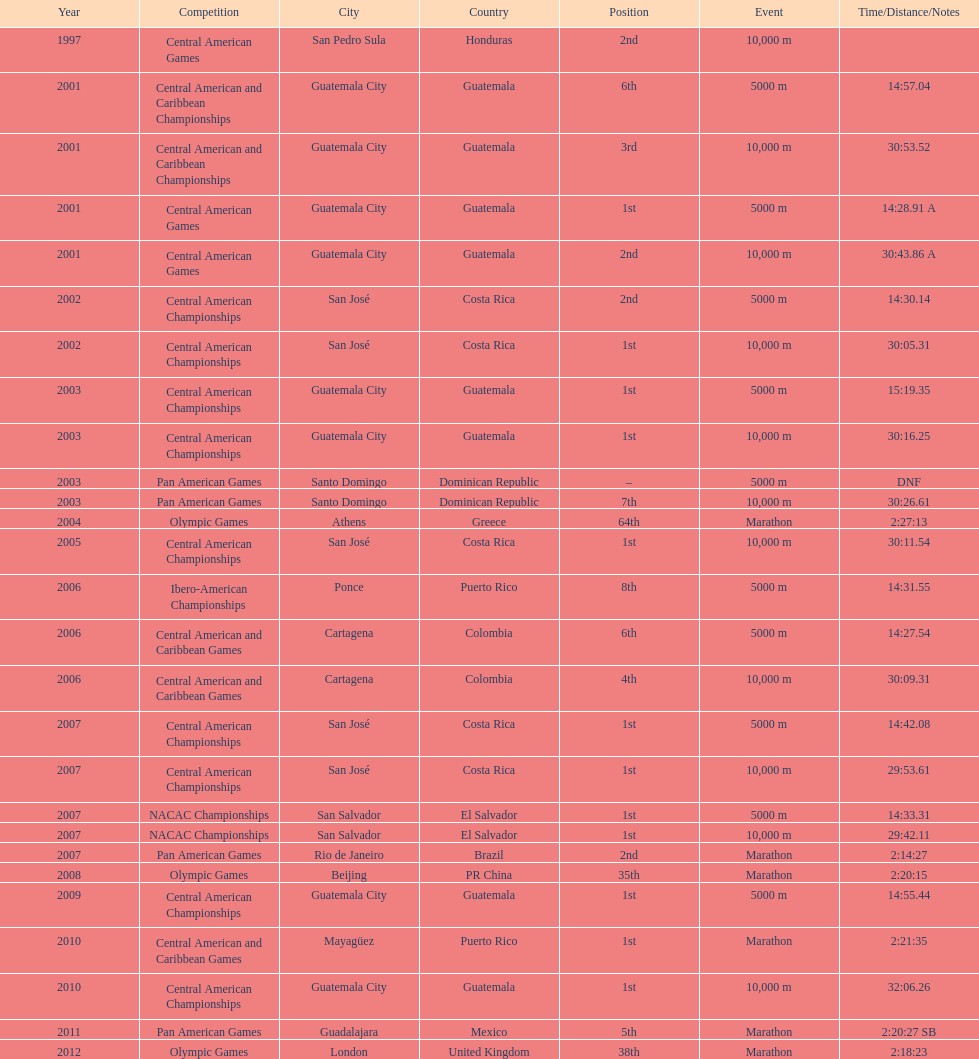Would you mind parsing the complete table? {'header': ['Year', 'Competition', 'City', 'Country', 'Position', 'Event', 'Time/Distance/Notes'], 'rows': [['1997', 'Central American Games', 'San Pedro Sula', 'Honduras', '2nd', '10,000 m', ''], ['2001', 'Central American and Caribbean Championships', 'Guatemala City', 'Guatemala', '6th', '5000 m', '14:57.04'], ['2001', 'Central American and Caribbean Championships', 'Guatemala City', 'Guatemala', '3rd', '10,000 m', '30:53.52'], ['2001', 'Central American Games', 'Guatemala City', 'Guatemala', '1st', '5000 m', '14:28.91 A'], ['2001', 'Central American Games', 'Guatemala City', 'Guatemala', '2nd', '10,000 m', '30:43.86 A'], ['2002', 'Central American Championships', 'San José', 'Costa Rica', '2nd', '5000 m', '14:30.14'], ['2002', 'Central American Championships', 'San José', 'Costa Rica', '1st', '10,000 m', '30:05.31'], ['2003', 'Central American Championships', 'Guatemala City', 'Guatemala', '1st', '5000 m', '15:19.35'], ['2003', 'Central American Championships', 'Guatemala City', 'Guatemala', '1st', '10,000 m', '30:16.25'], ['2003', 'Pan American Games', 'Santo Domingo', 'Dominican Republic', '–', '5000 m', 'DNF'], ['2003', 'Pan American Games', 'Santo Domingo', 'Dominican Republic', '7th', '10,000 m', '30:26.61'], ['2004', 'Olympic Games', 'Athens', 'Greece', '64th', 'Marathon', '2:27:13'], ['2005', 'Central American Championships', 'San José', 'Costa Rica', '1st', '10,000 m', '30:11.54'], ['2006', 'Ibero-American Championships', 'Ponce', 'Puerto Rico', '8th', '5000 m', '14:31.55'], ['2006', 'Central American and Caribbean Games', 'Cartagena', 'Colombia', '6th', '5000 m', '14:27.54'], ['2006', 'Central American and Caribbean Games', 'Cartagena', 'Colombia', '4th', '10,000 m', '30:09.31'], ['2007', 'Central American Championships', 'San José', 'Costa Rica', '1st', '5000 m', '14:42.08'], ['2007', 'Central American Championships', 'San José', 'Costa Rica', '1st', '10,000 m', '29:53.61'], ['2007', 'NACAC Championships', 'San Salvador', 'El Salvador', '1st', '5000 m', '14:33.31'], ['2007', 'NACAC Championships', 'San Salvador', 'El Salvador', '1st', '10,000 m', '29:42.11'], ['2007', 'Pan American Games', 'Rio de Janeiro', 'Brazil', '2nd', 'Marathon', '2:14:27'], ['2008', 'Olympic Games', 'Beijing', 'PR China', '35th', 'Marathon', '2:20:15'], ['2009', 'Central American Championships', 'Guatemala City', 'Guatemala', '1st', '5000 m', '14:55.44'], ['2010', 'Central American and Caribbean Games', 'Mayagüez', 'Puerto Rico', '1st', 'Marathon', '2:21:35'], ['2010', 'Central American Championships', 'Guatemala City', 'Guatemala', '1st', '10,000 m', '32:06.26'], ['2011', 'Pan American Games', 'Guadalajara', 'Mexico', '5th', 'Marathon', '2:20:27 SB'], ['2012', 'Olympic Games', 'London', 'United Kingdom', '38th', 'Marathon', '2:18:23']]} Where was the only 64th position held? Athens, Greece. 